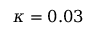Convert formula to latex. <formula><loc_0><loc_0><loc_500><loc_500>\kappa = 0 . 0 3</formula> 